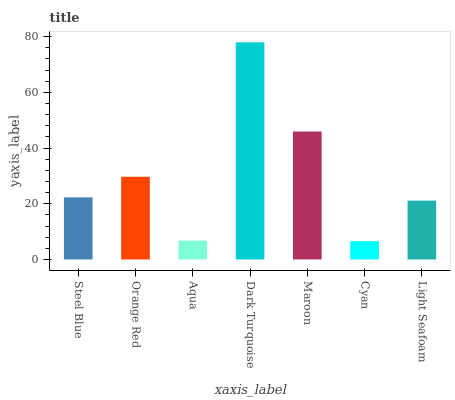Is Cyan the minimum?
Answer yes or no. Yes. Is Dark Turquoise the maximum?
Answer yes or no. Yes. Is Orange Red the minimum?
Answer yes or no. No. Is Orange Red the maximum?
Answer yes or no. No. Is Orange Red greater than Steel Blue?
Answer yes or no. Yes. Is Steel Blue less than Orange Red?
Answer yes or no. Yes. Is Steel Blue greater than Orange Red?
Answer yes or no. No. Is Orange Red less than Steel Blue?
Answer yes or no. No. Is Steel Blue the high median?
Answer yes or no. Yes. Is Steel Blue the low median?
Answer yes or no. Yes. Is Cyan the high median?
Answer yes or no. No. Is Cyan the low median?
Answer yes or no. No. 